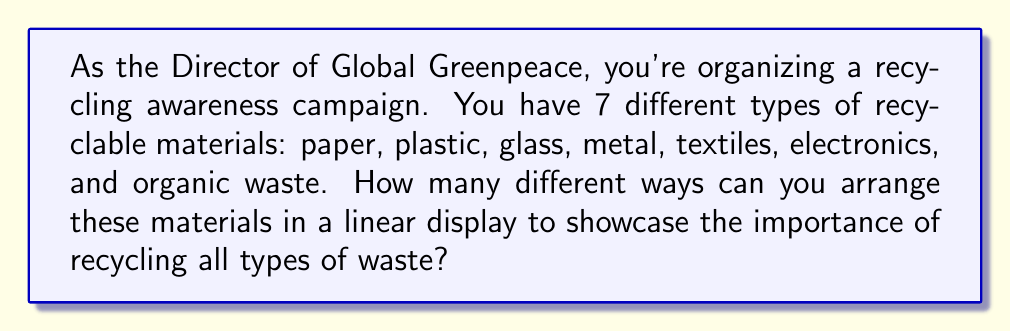Provide a solution to this math problem. To solve this problem, we need to use the concept of permutations. Since we are arranging all 7 materials in different orders, and each material is used exactly once, this is a straightforward permutation problem.

The number of permutations of $n$ distinct objects is given by the factorial of $n$, denoted as $n!$.

In this case, we have 7 distinct materials, so:

$n = 7$

The number of permutations is:

$7! = 7 \times 6 \times 5 \times 4 \times 3 \times 2 \times 1$

Let's calculate this step by step:

$7 \times 6 = 42$
$42 \times 5 = 210$
$210 \times 4 = 840$
$840 \times 3 = 2,520$
$2,520 \times 2 = 5,040$
$5,040 \times 1 = 5,040$

Therefore, the number of different ways to arrange the 7 recyclable materials is 5,040.
Answer: 5,040 